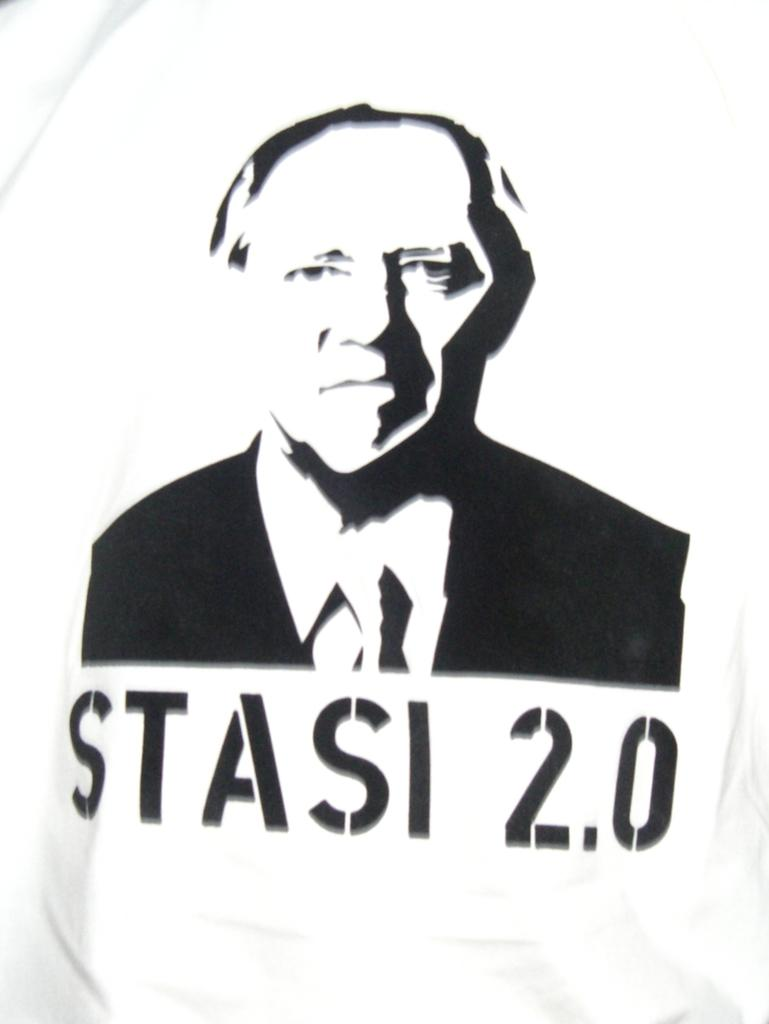What is present on the poster in the image? There is a poster in the image, and it features a person. What type of plantation can be seen in the background of the image? There is no plantation present in the image; it only features a poster with a person on it. How many cattle are visible in the image? There are no cattle present in the image. 